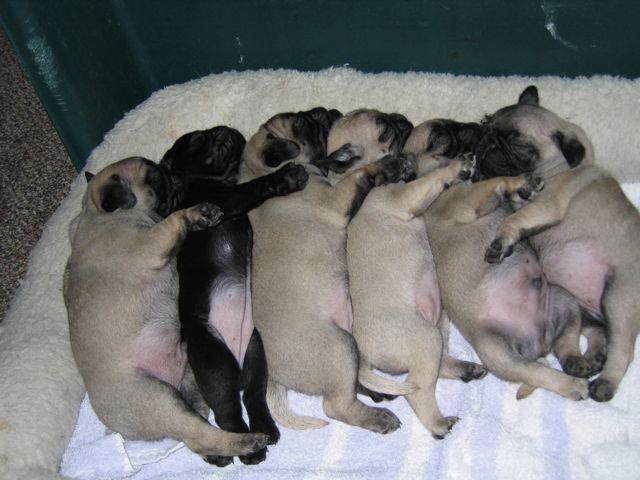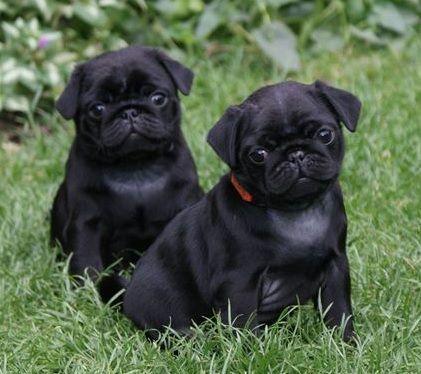The first image is the image on the left, the second image is the image on the right. Analyze the images presented: Is the assertion "One of the dogs is standing in the grass." valid? Answer yes or no. No. The first image is the image on the left, the second image is the image on the right. For the images displayed, is the sentence "An image shows one black pug, with its tongue out." factually correct? Answer yes or no. No. 